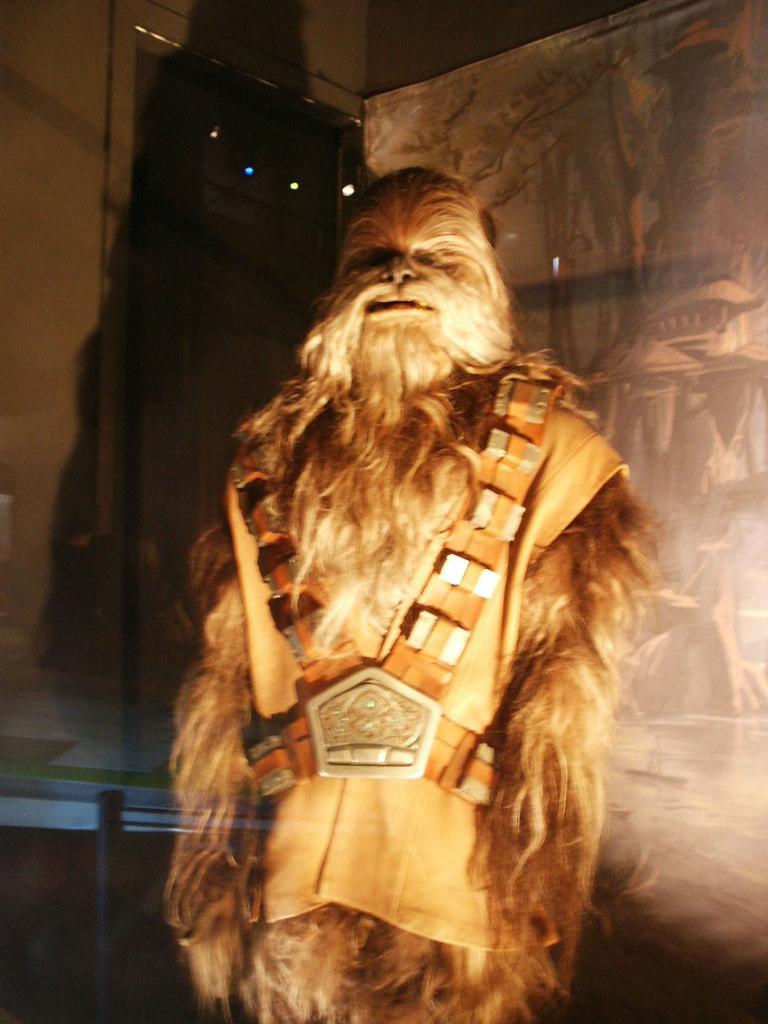Can you describe this image briefly? In this image I can see a brown colored object which is in the shape of a person. I can see brown colored clothes and brown colored belt on it. In the background I can see the banner, few lights and the wall. 